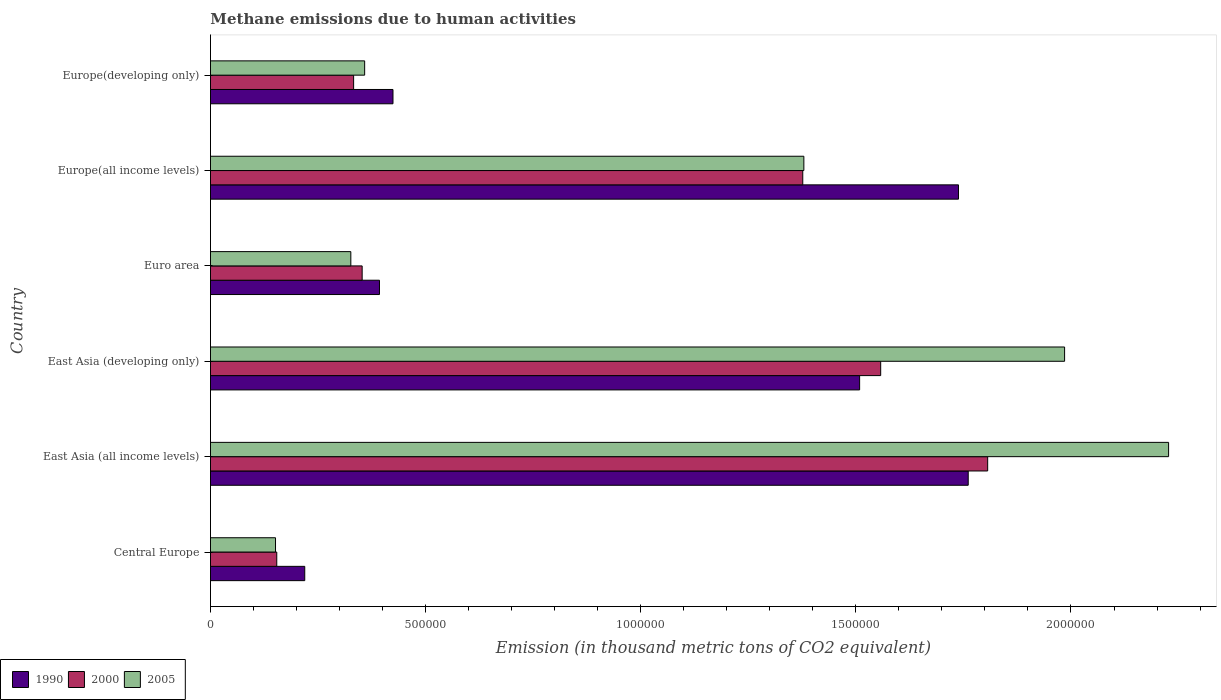How many different coloured bars are there?
Keep it short and to the point. 3. How many groups of bars are there?
Provide a succinct answer. 6. Are the number of bars per tick equal to the number of legend labels?
Your answer should be very brief. Yes. Are the number of bars on each tick of the Y-axis equal?
Offer a terse response. Yes. What is the label of the 1st group of bars from the top?
Keep it short and to the point. Europe(developing only). In how many cases, is the number of bars for a given country not equal to the number of legend labels?
Keep it short and to the point. 0. What is the amount of methane emitted in 1990 in East Asia (developing only)?
Offer a terse response. 1.51e+06. Across all countries, what is the maximum amount of methane emitted in 2005?
Your answer should be very brief. 2.23e+06. Across all countries, what is the minimum amount of methane emitted in 2005?
Provide a succinct answer. 1.51e+05. In which country was the amount of methane emitted in 2000 maximum?
Give a very brief answer. East Asia (all income levels). In which country was the amount of methane emitted in 2005 minimum?
Keep it short and to the point. Central Europe. What is the total amount of methane emitted in 2005 in the graph?
Your answer should be very brief. 6.43e+06. What is the difference between the amount of methane emitted in 2000 in Europe(all income levels) and that in Europe(developing only)?
Your response must be concise. 1.04e+06. What is the difference between the amount of methane emitted in 2000 in Europe(all income levels) and the amount of methane emitted in 2005 in Europe(developing only)?
Your answer should be very brief. 1.02e+06. What is the average amount of methane emitted in 2005 per country?
Ensure brevity in your answer.  1.07e+06. What is the difference between the amount of methane emitted in 1990 and amount of methane emitted in 2005 in Europe(all income levels)?
Keep it short and to the point. 3.59e+05. What is the ratio of the amount of methane emitted in 2000 in East Asia (all income levels) to that in East Asia (developing only)?
Your answer should be compact. 1.16. Is the amount of methane emitted in 1990 in East Asia (all income levels) less than that in Europe(all income levels)?
Your response must be concise. No. What is the difference between the highest and the second highest amount of methane emitted in 1990?
Provide a short and direct response. 2.26e+04. What is the difference between the highest and the lowest amount of methane emitted in 2000?
Keep it short and to the point. 1.65e+06. What does the 1st bar from the top in East Asia (all income levels) represents?
Offer a terse response. 2005. What does the 1st bar from the bottom in Central Europe represents?
Provide a succinct answer. 1990. Are all the bars in the graph horizontal?
Offer a very short reply. Yes. How many countries are there in the graph?
Make the answer very short. 6. Are the values on the major ticks of X-axis written in scientific E-notation?
Give a very brief answer. No. Does the graph contain any zero values?
Keep it short and to the point. No. Does the graph contain grids?
Provide a succinct answer. No. Where does the legend appear in the graph?
Offer a terse response. Bottom left. What is the title of the graph?
Your response must be concise. Methane emissions due to human activities. What is the label or title of the X-axis?
Provide a succinct answer. Emission (in thousand metric tons of CO2 equivalent). What is the Emission (in thousand metric tons of CO2 equivalent) of 1990 in Central Europe?
Keep it short and to the point. 2.19e+05. What is the Emission (in thousand metric tons of CO2 equivalent) of 2000 in Central Europe?
Offer a very short reply. 1.54e+05. What is the Emission (in thousand metric tons of CO2 equivalent) of 2005 in Central Europe?
Provide a short and direct response. 1.51e+05. What is the Emission (in thousand metric tons of CO2 equivalent) in 1990 in East Asia (all income levels)?
Make the answer very short. 1.76e+06. What is the Emission (in thousand metric tons of CO2 equivalent) in 2000 in East Asia (all income levels)?
Provide a succinct answer. 1.81e+06. What is the Emission (in thousand metric tons of CO2 equivalent) in 2005 in East Asia (all income levels)?
Offer a terse response. 2.23e+06. What is the Emission (in thousand metric tons of CO2 equivalent) in 1990 in East Asia (developing only)?
Make the answer very short. 1.51e+06. What is the Emission (in thousand metric tons of CO2 equivalent) in 2000 in East Asia (developing only)?
Offer a very short reply. 1.56e+06. What is the Emission (in thousand metric tons of CO2 equivalent) of 2005 in East Asia (developing only)?
Ensure brevity in your answer.  1.99e+06. What is the Emission (in thousand metric tons of CO2 equivalent) of 1990 in Euro area?
Provide a short and direct response. 3.93e+05. What is the Emission (in thousand metric tons of CO2 equivalent) in 2000 in Euro area?
Provide a succinct answer. 3.53e+05. What is the Emission (in thousand metric tons of CO2 equivalent) of 2005 in Euro area?
Offer a very short reply. 3.26e+05. What is the Emission (in thousand metric tons of CO2 equivalent) in 1990 in Europe(all income levels)?
Provide a short and direct response. 1.74e+06. What is the Emission (in thousand metric tons of CO2 equivalent) in 2000 in Europe(all income levels)?
Give a very brief answer. 1.38e+06. What is the Emission (in thousand metric tons of CO2 equivalent) of 2005 in Europe(all income levels)?
Keep it short and to the point. 1.38e+06. What is the Emission (in thousand metric tons of CO2 equivalent) of 1990 in Europe(developing only)?
Provide a succinct answer. 4.24e+05. What is the Emission (in thousand metric tons of CO2 equivalent) of 2000 in Europe(developing only)?
Provide a short and direct response. 3.33e+05. What is the Emission (in thousand metric tons of CO2 equivalent) in 2005 in Europe(developing only)?
Give a very brief answer. 3.58e+05. Across all countries, what is the maximum Emission (in thousand metric tons of CO2 equivalent) in 1990?
Your response must be concise. 1.76e+06. Across all countries, what is the maximum Emission (in thousand metric tons of CO2 equivalent) in 2000?
Give a very brief answer. 1.81e+06. Across all countries, what is the maximum Emission (in thousand metric tons of CO2 equivalent) of 2005?
Your answer should be very brief. 2.23e+06. Across all countries, what is the minimum Emission (in thousand metric tons of CO2 equivalent) in 1990?
Ensure brevity in your answer.  2.19e+05. Across all countries, what is the minimum Emission (in thousand metric tons of CO2 equivalent) of 2000?
Give a very brief answer. 1.54e+05. Across all countries, what is the minimum Emission (in thousand metric tons of CO2 equivalent) of 2005?
Your answer should be very brief. 1.51e+05. What is the total Emission (in thousand metric tons of CO2 equivalent) in 1990 in the graph?
Make the answer very short. 6.04e+06. What is the total Emission (in thousand metric tons of CO2 equivalent) of 2000 in the graph?
Your response must be concise. 5.58e+06. What is the total Emission (in thousand metric tons of CO2 equivalent) of 2005 in the graph?
Your response must be concise. 6.43e+06. What is the difference between the Emission (in thousand metric tons of CO2 equivalent) in 1990 in Central Europe and that in East Asia (all income levels)?
Offer a very short reply. -1.54e+06. What is the difference between the Emission (in thousand metric tons of CO2 equivalent) of 2000 in Central Europe and that in East Asia (all income levels)?
Your answer should be compact. -1.65e+06. What is the difference between the Emission (in thousand metric tons of CO2 equivalent) in 2005 in Central Europe and that in East Asia (all income levels)?
Ensure brevity in your answer.  -2.08e+06. What is the difference between the Emission (in thousand metric tons of CO2 equivalent) in 1990 in Central Europe and that in East Asia (developing only)?
Provide a short and direct response. -1.29e+06. What is the difference between the Emission (in thousand metric tons of CO2 equivalent) of 2000 in Central Europe and that in East Asia (developing only)?
Give a very brief answer. -1.40e+06. What is the difference between the Emission (in thousand metric tons of CO2 equivalent) in 2005 in Central Europe and that in East Asia (developing only)?
Offer a terse response. -1.83e+06. What is the difference between the Emission (in thousand metric tons of CO2 equivalent) of 1990 in Central Europe and that in Euro area?
Ensure brevity in your answer.  -1.74e+05. What is the difference between the Emission (in thousand metric tons of CO2 equivalent) of 2000 in Central Europe and that in Euro area?
Provide a short and direct response. -1.98e+05. What is the difference between the Emission (in thousand metric tons of CO2 equivalent) of 2005 in Central Europe and that in Euro area?
Provide a succinct answer. -1.75e+05. What is the difference between the Emission (in thousand metric tons of CO2 equivalent) in 1990 in Central Europe and that in Europe(all income levels)?
Keep it short and to the point. -1.52e+06. What is the difference between the Emission (in thousand metric tons of CO2 equivalent) of 2000 in Central Europe and that in Europe(all income levels)?
Make the answer very short. -1.22e+06. What is the difference between the Emission (in thousand metric tons of CO2 equivalent) of 2005 in Central Europe and that in Europe(all income levels)?
Make the answer very short. -1.23e+06. What is the difference between the Emission (in thousand metric tons of CO2 equivalent) of 1990 in Central Europe and that in Europe(developing only)?
Ensure brevity in your answer.  -2.05e+05. What is the difference between the Emission (in thousand metric tons of CO2 equivalent) in 2000 in Central Europe and that in Europe(developing only)?
Provide a succinct answer. -1.79e+05. What is the difference between the Emission (in thousand metric tons of CO2 equivalent) in 2005 in Central Europe and that in Europe(developing only)?
Provide a short and direct response. -2.07e+05. What is the difference between the Emission (in thousand metric tons of CO2 equivalent) in 1990 in East Asia (all income levels) and that in East Asia (developing only)?
Keep it short and to the point. 2.52e+05. What is the difference between the Emission (in thousand metric tons of CO2 equivalent) of 2000 in East Asia (all income levels) and that in East Asia (developing only)?
Provide a short and direct response. 2.49e+05. What is the difference between the Emission (in thousand metric tons of CO2 equivalent) in 2005 in East Asia (all income levels) and that in East Asia (developing only)?
Your answer should be compact. 2.42e+05. What is the difference between the Emission (in thousand metric tons of CO2 equivalent) of 1990 in East Asia (all income levels) and that in Euro area?
Offer a terse response. 1.37e+06. What is the difference between the Emission (in thousand metric tons of CO2 equivalent) in 2000 in East Asia (all income levels) and that in Euro area?
Provide a short and direct response. 1.45e+06. What is the difference between the Emission (in thousand metric tons of CO2 equivalent) in 2005 in East Asia (all income levels) and that in Euro area?
Offer a terse response. 1.90e+06. What is the difference between the Emission (in thousand metric tons of CO2 equivalent) in 1990 in East Asia (all income levels) and that in Europe(all income levels)?
Make the answer very short. 2.26e+04. What is the difference between the Emission (in thousand metric tons of CO2 equivalent) in 2000 in East Asia (all income levels) and that in Europe(all income levels)?
Your response must be concise. 4.30e+05. What is the difference between the Emission (in thousand metric tons of CO2 equivalent) of 2005 in East Asia (all income levels) and that in Europe(all income levels)?
Offer a terse response. 8.48e+05. What is the difference between the Emission (in thousand metric tons of CO2 equivalent) in 1990 in East Asia (all income levels) and that in Europe(developing only)?
Your response must be concise. 1.34e+06. What is the difference between the Emission (in thousand metric tons of CO2 equivalent) in 2000 in East Asia (all income levels) and that in Europe(developing only)?
Your answer should be very brief. 1.47e+06. What is the difference between the Emission (in thousand metric tons of CO2 equivalent) of 2005 in East Asia (all income levels) and that in Europe(developing only)?
Your answer should be compact. 1.87e+06. What is the difference between the Emission (in thousand metric tons of CO2 equivalent) in 1990 in East Asia (developing only) and that in Euro area?
Keep it short and to the point. 1.12e+06. What is the difference between the Emission (in thousand metric tons of CO2 equivalent) in 2000 in East Asia (developing only) and that in Euro area?
Keep it short and to the point. 1.21e+06. What is the difference between the Emission (in thousand metric tons of CO2 equivalent) of 2005 in East Asia (developing only) and that in Euro area?
Your answer should be very brief. 1.66e+06. What is the difference between the Emission (in thousand metric tons of CO2 equivalent) of 1990 in East Asia (developing only) and that in Europe(all income levels)?
Make the answer very short. -2.30e+05. What is the difference between the Emission (in thousand metric tons of CO2 equivalent) in 2000 in East Asia (developing only) and that in Europe(all income levels)?
Keep it short and to the point. 1.81e+05. What is the difference between the Emission (in thousand metric tons of CO2 equivalent) in 2005 in East Asia (developing only) and that in Europe(all income levels)?
Provide a succinct answer. 6.06e+05. What is the difference between the Emission (in thousand metric tons of CO2 equivalent) in 1990 in East Asia (developing only) and that in Europe(developing only)?
Make the answer very short. 1.08e+06. What is the difference between the Emission (in thousand metric tons of CO2 equivalent) in 2000 in East Asia (developing only) and that in Europe(developing only)?
Give a very brief answer. 1.23e+06. What is the difference between the Emission (in thousand metric tons of CO2 equivalent) in 2005 in East Asia (developing only) and that in Europe(developing only)?
Keep it short and to the point. 1.63e+06. What is the difference between the Emission (in thousand metric tons of CO2 equivalent) of 1990 in Euro area and that in Europe(all income levels)?
Offer a terse response. -1.35e+06. What is the difference between the Emission (in thousand metric tons of CO2 equivalent) in 2000 in Euro area and that in Europe(all income levels)?
Provide a short and direct response. -1.02e+06. What is the difference between the Emission (in thousand metric tons of CO2 equivalent) in 2005 in Euro area and that in Europe(all income levels)?
Offer a very short reply. -1.05e+06. What is the difference between the Emission (in thousand metric tons of CO2 equivalent) of 1990 in Euro area and that in Europe(developing only)?
Give a very brief answer. -3.14e+04. What is the difference between the Emission (in thousand metric tons of CO2 equivalent) in 2000 in Euro area and that in Europe(developing only)?
Give a very brief answer. 1.98e+04. What is the difference between the Emission (in thousand metric tons of CO2 equivalent) in 2005 in Euro area and that in Europe(developing only)?
Offer a very short reply. -3.22e+04. What is the difference between the Emission (in thousand metric tons of CO2 equivalent) in 1990 in Europe(all income levels) and that in Europe(developing only)?
Offer a terse response. 1.31e+06. What is the difference between the Emission (in thousand metric tons of CO2 equivalent) of 2000 in Europe(all income levels) and that in Europe(developing only)?
Ensure brevity in your answer.  1.04e+06. What is the difference between the Emission (in thousand metric tons of CO2 equivalent) in 2005 in Europe(all income levels) and that in Europe(developing only)?
Offer a terse response. 1.02e+06. What is the difference between the Emission (in thousand metric tons of CO2 equivalent) in 1990 in Central Europe and the Emission (in thousand metric tons of CO2 equivalent) in 2000 in East Asia (all income levels)?
Offer a very short reply. -1.59e+06. What is the difference between the Emission (in thousand metric tons of CO2 equivalent) of 1990 in Central Europe and the Emission (in thousand metric tons of CO2 equivalent) of 2005 in East Asia (all income levels)?
Offer a terse response. -2.01e+06. What is the difference between the Emission (in thousand metric tons of CO2 equivalent) in 2000 in Central Europe and the Emission (in thousand metric tons of CO2 equivalent) in 2005 in East Asia (all income levels)?
Your answer should be compact. -2.07e+06. What is the difference between the Emission (in thousand metric tons of CO2 equivalent) in 1990 in Central Europe and the Emission (in thousand metric tons of CO2 equivalent) in 2000 in East Asia (developing only)?
Provide a short and direct response. -1.34e+06. What is the difference between the Emission (in thousand metric tons of CO2 equivalent) of 1990 in Central Europe and the Emission (in thousand metric tons of CO2 equivalent) of 2005 in East Asia (developing only)?
Your response must be concise. -1.77e+06. What is the difference between the Emission (in thousand metric tons of CO2 equivalent) of 2000 in Central Europe and the Emission (in thousand metric tons of CO2 equivalent) of 2005 in East Asia (developing only)?
Give a very brief answer. -1.83e+06. What is the difference between the Emission (in thousand metric tons of CO2 equivalent) in 1990 in Central Europe and the Emission (in thousand metric tons of CO2 equivalent) in 2000 in Euro area?
Offer a very short reply. -1.33e+05. What is the difference between the Emission (in thousand metric tons of CO2 equivalent) of 1990 in Central Europe and the Emission (in thousand metric tons of CO2 equivalent) of 2005 in Euro area?
Your answer should be compact. -1.07e+05. What is the difference between the Emission (in thousand metric tons of CO2 equivalent) in 2000 in Central Europe and the Emission (in thousand metric tons of CO2 equivalent) in 2005 in Euro area?
Your response must be concise. -1.72e+05. What is the difference between the Emission (in thousand metric tons of CO2 equivalent) of 1990 in Central Europe and the Emission (in thousand metric tons of CO2 equivalent) of 2000 in Europe(all income levels)?
Provide a succinct answer. -1.16e+06. What is the difference between the Emission (in thousand metric tons of CO2 equivalent) of 1990 in Central Europe and the Emission (in thousand metric tons of CO2 equivalent) of 2005 in Europe(all income levels)?
Your answer should be compact. -1.16e+06. What is the difference between the Emission (in thousand metric tons of CO2 equivalent) in 2000 in Central Europe and the Emission (in thousand metric tons of CO2 equivalent) in 2005 in Europe(all income levels)?
Provide a succinct answer. -1.23e+06. What is the difference between the Emission (in thousand metric tons of CO2 equivalent) of 1990 in Central Europe and the Emission (in thousand metric tons of CO2 equivalent) of 2000 in Europe(developing only)?
Your response must be concise. -1.14e+05. What is the difference between the Emission (in thousand metric tons of CO2 equivalent) of 1990 in Central Europe and the Emission (in thousand metric tons of CO2 equivalent) of 2005 in Europe(developing only)?
Provide a short and direct response. -1.39e+05. What is the difference between the Emission (in thousand metric tons of CO2 equivalent) of 2000 in Central Europe and the Emission (in thousand metric tons of CO2 equivalent) of 2005 in Europe(developing only)?
Your answer should be very brief. -2.04e+05. What is the difference between the Emission (in thousand metric tons of CO2 equivalent) of 1990 in East Asia (all income levels) and the Emission (in thousand metric tons of CO2 equivalent) of 2000 in East Asia (developing only)?
Offer a very short reply. 2.03e+05. What is the difference between the Emission (in thousand metric tons of CO2 equivalent) in 1990 in East Asia (all income levels) and the Emission (in thousand metric tons of CO2 equivalent) in 2005 in East Asia (developing only)?
Provide a short and direct response. -2.24e+05. What is the difference between the Emission (in thousand metric tons of CO2 equivalent) of 2000 in East Asia (all income levels) and the Emission (in thousand metric tons of CO2 equivalent) of 2005 in East Asia (developing only)?
Keep it short and to the point. -1.79e+05. What is the difference between the Emission (in thousand metric tons of CO2 equivalent) in 1990 in East Asia (all income levels) and the Emission (in thousand metric tons of CO2 equivalent) in 2000 in Euro area?
Your response must be concise. 1.41e+06. What is the difference between the Emission (in thousand metric tons of CO2 equivalent) in 1990 in East Asia (all income levels) and the Emission (in thousand metric tons of CO2 equivalent) in 2005 in Euro area?
Make the answer very short. 1.43e+06. What is the difference between the Emission (in thousand metric tons of CO2 equivalent) of 2000 in East Asia (all income levels) and the Emission (in thousand metric tons of CO2 equivalent) of 2005 in Euro area?
Ensure brevity in your answer.  1.48e+06. What is the difference between the Emission (in thousand metric tons of CO2 equivalent) of 1990 in East Asia (all income levels) and the Emission (in thousand metric tons of CO2 equivalent) of 2000 in Europe(all income levels)?
Provide a short and direct response. 3.85e+05. What is the difference between the Emission (in thousand metric tons of CO2 equivalent) in 1990 in East Asia (all income levels) and the Emission (in thousand metric tons of CO2 equivalent) in 2005 in Europe(all income levels)?
Offer a terse response. 3.82e+05. What is the difference between the Emission (in thousand metric tons of CO2 equivalent) in 2000 in East Asia (all income levels) and the Emission (in thousand metric tons of CO2 equivalent) in 2005 in Europe(all income levels)?
Your answer should be compact. 4.27e+05. What is the difference between the Emission (in thousand metric tons of CO2 equivalent) of 1990 in East Asia (all income levels) and the Emission (in thousand metric tons of CO2 equivalent) of 2000 in Europe(developing only)?
Keep it short and to the point. 1.43e+06. What is the difference between the Emission (in thousand metric tons of CO2 equivalent) of 1990 in East Asia (all income levels) and the Emission (in thousand metric tons of CO2 equivalent) of 2005 in Europe(developing only)?
Keep it short and to the point. 1.40e+06. What is the difference between the Emission (in thousand metric tons of CO2 equivalent) in 2000 in East Asia (all income levels) and the Emission (in thousand metric tons of CO2 equivalent) in 2005 in Europe(developing only)?
Your answer should be very brief. 1.45e+06. What is the difference between the Emission (in thousand metric tons of CO2 equivalent) in 1990 in East Asia (developing only) and the Emission (in thousand metric tons of CO2 equivalent) in 2000 in Euro area?
Give a very brief answer. 1.16e+06. What is the difference between the Emission (in thousand metric tons of CO2 equivalent) of 1990 in East Asia (developing only) and the Emission (in thousand metric tons of CO2 equivalent) of 2005 in Euro area?
Make the answer very short. 1.18e+06. What is the difference between the Emission (in thousand metric tons of CO2 equivalent) in 2000 in East Asia (developing only) and the Emission (in thousand metric tons of CO2 equivalent) in 2005 in Euro area?
Make the answer very short. 1.23e+06. What is the difference between the Emission (in thousand metric tons of CO2 equivalent) in 1990 in East Asia (developing only) and the Emission (in thousand metric tons of CO2 equivalent) in 2000 in Europe(all income levels)?
Keep it short and to the point. 1.32e+05. What is the difference between the Emission (in thousand metric tons of CO2 equivalent) of 1990 in East Asia (developing only) and the Emission (in thousand metric tons of CO2 equivalent) of 2005 in Europe(all income levels)?
Keep it short and to the point. 1.30e+05. What is the difference between the Emission (in thousand metric tons of CO2 equivalent) in 2000 in East Asia (developing only) and the Emission (in thousand metric tons of CO2 equivalent) in 2005 in Europe(all income levels)?
Give a very brief answer. 1.79e+05. What is the difference between the Emission (in thousand metric tons of CO2 equivalent) in 1990 in East Asia (developing only) and the Emission (in thousand metric tons of CO2 equivalent) in 2000 in Europe(developing only)?
Your response must be concise. 1.18e+06. What is the difference between the Emission (in thousand metric tons of CO2 equivalent) of 1990 in East Asia (developing only) and the Emission (in thousand metric tons of CO2 equivalent) of 2005 in Europe(developing only)?
Keep it short and to the point. 1.15e+06. What is the difference between the Emission (in thousand metric tons of CO2 equivalent) of 2000 in East Asia (developing only) and the Emission (in thousand metric tons of CO2 equivalent) of 2005 in Europe(developing only)?
Your answer should be compact. 1.20e+06. What is the difference between the Emission (in thousand metric tons of CO2 equivalent) of 1990 in Euro area and the Emission (in thousand metric tons of CO2 equivalent) of 2000 in Europe(all income levels)?
Provide a succinct answer. -9.84e+05. What is the difference between the Emission (in thousand metric tons of CO2 equivalent) in 1990 in Euro area and the Emission (in thousand metric tons of CO2 equivalent) in 2005 in Europe(all income levels)?
Your answer should be compact. -9.86e+05. What is the difference between the Emission (in thousand metric tons of CO2 equivalent) of 2000 in Euro area and the Emission (in thousand metric tons of CO2 equivalent) of 2005 in Europe(all income levels)?
Your answer should be very brief. -1.03e+06. What is the difference between the Emission (in thousand metric tons of CO2 equivalent) in 1990 in Euro area and the Emission (in thousand metric tons of CO2 equivalent) in 2000 in Europe(developing only)?
Give a very brief answer. 6.01e+04. What is the difference between the Emission (in thousand metric tons of CO2 equivalent) of 1990 in Euro area and the Emission (in thousand metric tons of CO2 equivalent) of 2005 in Europe(developing only)?
Your answer should be compact. 3.44e+04. What is the difference between the Emission (in thousand metric tons of CO2 equivalent) in 2000 in Euro area and the Emission (in thousand metric tons of CO2 equivalent) in 2005 in Europe(developing only)?
Your answer should be compact. -5815.2. What is the difference between the Emission (in thousand metric tons of CO2 equivalent) in 1990 in Europe(all income levels) and the Emission (in thousand metric tons of CO2 equivalent) in 2000 in Europe(developing only)?
Ensure brevity in your answer.  1.41e+06. What is the difference between the Emission (in thousand metric tons of CO2 equivalent) of 1990 in Europe(all income levels) and the Emission (in thousand metric tons of CO2 equivalent) of 2005 in Europe(developing only)?
Your answer should be very brief. 1.38e+06. What is the difference between the Emission (in thousand metric tons of CO2 equivalent) of 2000 in Europe(all income levels) and the Emission (in thousand metric tons of CO2 equivalent) of 2005 in Europe(developing only)?
Provide a succinct answer. 1.02e+06. What is the average Emission (in thousand metric tons of CO2 equivalent) of 1990 per country?
Your response must be concise. 1.01e+06. What is the average Emission (in thousand metric tons of CO2 equivalent) in 2000 per country?
Keep it short and to the point. 9.30e+05. What is the average Emission (in thousand metric tons of CO2 equivalent) in 2005 per country?
Offer a very short reply. 1.07e+06. What is the difference between the Emission (in thousand metric tons of CO2 equivalent) of 1990 and Emission (in thousand metric tons of CO2 equivalent) of 2000 in Central Europe?
Provide a short and direct response. 6.50e+04. What is the difference between the Emission (in thousand metric tons of CO2 equivalent) of 1990 and Emission (in thousand metric tons of CO2 equivalent) of 2005 in Central Europe?
Your response must be concise. 6.80e+04. What is the difference between the Emission (in thousand metric tons of CO2 equivalent) in 2000 and Emission (in thousand metric tons of CO2 equivalent) in 2005 in Central Europe?
Provide a succinct answer. 2935.3. What is the difference between the Emission (in thousand metric tons of CO2 equivalent) of 1990 and Emission (in thousand metric tons of CO2 equivalent) of 2000 in East Asia (all income levels)?
Ensure brevity in your answer.  -4.52e+04. What is the difference between the Emission (in thousand metric tons of CO2 equivalent) of 1990 and Emission (in thousand metric tons of CO2 equivalent) of 2005 in East Asia (all income levels)?
Provide a succinct answer. -4.66e+05. What is the difference between the Emission (in thousand metric tons of CO2 equivalent) of 2000 and Emission (in thousand metric tons of CO2 equivalent) of 2005 in East Asia (all income levels)?
Give a very brief answer. -4.20e+05. What is the difference between the Emission (in thousand metric tons of CO2 equivalent) in 1990 and Emission (in thousand metric tons of CO2 equivalent) in 2000 in East Asia (developing only)?
Make the answer very short. -4.90e+04. What is the difference between the Emission (in thousand metric tons of CO2 equivalent) of 1990 and Emission (in thousand metric tons of CO2 equivalent) of 2005 in East Asia (developing only)?
Keep it short and to the point. -4.76e+05. What is the difference between the Emission (in thousand metric tons of CO2 equivalent) of 2000 and Emission (in thousand metric tons of CO2 equivalent) of 2005 in East Asia (developing only)?
Ensure brevity in your answer.  -4.27e+05. What is the difference between the Emission (in thousand metric tons of CO2 equivalent) in 1990 and Emission (in thousand metric tons of CO2 equivalent) in 2000 in Euro area?
Provide a short and direct response. 4.02e+04. What is the difference between the Emission (in thousand metric tons of CO2 equivalent) of 1990 and Emission (in thousand metric tons of CO2 equivalent) of 2005 in Euro area?
Your answer should be very brief. 6.66e+04. What is the difference between the Emission (in thousand metric tons of CO2 equivalent) of 2000 and Emission (in thousand metric tons of CO2 equivalent) of 2005 in Euro area?
Give a very brief answer. 2.63e+04. What is the difference between the Emission (in thousand metric tons of CO2 equivalent) in 1990 and Emission (in thousand metric tons of CO2 equivalent) in 2000 in Europe(all income levels)?
Your response must be concise. 3.62e+05. What is the difference between the Emission (in thousand metric tons of CO2 equivalent) of 1990 and Emission (in thousand metric tons of CO2 equivalent) of 2005 in Europe(all income levels)?
Offer a very short reply. 3.59e+05. What is the difference between the Emission (in thousand metric tons of CO2 equivalent) of 2000 and Emission (in thousand metric tons of CO2 equivalent) of 2005 in Europe(all income levels)?
Your response must be concise. -2537.9. What is the difference between the Emission (in thousand metric tons of CO2 equivalent) of 1990 and Emission (in thousand metric tons of CO2 equivalent) of 2000 in Europe(developing only)?
Your response must be concise. 9.15e+04. What is the difference between the Emission (in thousand metric tons of CO2 equivalent) of 1990 and Emission (in thousand metric tons of CO2 equivalent) of 2005 in Europe(developing only)?
Your answer should be compact. 6.58e+04. What is the difference between the Emission (in thousand metric tons of CO2 equivalent) of 2000 and Emission (in thousand metric tons of CO2 equivalent) of 2005 in Europe(developing only)?
Your answer should be very brief. -2.56e+04. What is the ratio of the Emission (in thousand metric tons of CO2 equivalent) of 1990 in Central Europe to that in East Asia (all income levels)?
Offer a very short reply. 0.12. What is the ratio of the Emission (in thousand metric tons of CO2 equivalent) of 2000 in Central Europe to that in East Asia (all income levels)?
Give a very brief answer. 0.09. What is the ratio of the Emission (in thousand metric tons of CO2 equivalent) of 2005 in Central Europe to that in East Asia (all income levels)?
Give a very brief answer. 0.07. What is the ratio of the Emission (in thousand metric tons of CO2 equivalent) in 1990 in Central Europe to that in East Asia (developing only)?
Offer a very short reply. 0.15. What is the ratio of the Emission (in thousand metric tons of CO2 equivalent) of 2000 in Central Europe to that in East Asia (developing only)?
Ensure brevity in your answer.  0.1. What is the ratio of the Emission (in thousand metric tons of CO2 equivalent) of 2005 in Central Europe to that in East Asia (developing only)?
Your answer should be compact. 0.08. What is the ratio of the Emission (in thousand metric tons of CO2 equivalent) in 1990 in Central Europe to that in Euro area?
Make the answer very short. 0.56. What is the ratio of the Emission (in thousand metric tons of CO2 equivalent) in 2000 in Central Europe to that in Euro area?
Your answer should be very brief. 0.44. What is the ratio of the Emission (in thousand metric tons of CO2 equivalent) in 2005 in Central Europe to that in Euro area?
Give a very brief answer. 0.46. What is the ratio of the Emission (in thousand metric tons of CO2 equivalent) of 1990 in Central Europe to that in Europe(all income levels)?
Make the answer very short. 0.13. What is the ratio of the Emission (in thousand metric tons of CO2 equivalent) of 2000 in Central Europe to that in Europe(all income levels)?
Make the answer very short. 0.11. What is the ratio of the Emission (in thousand metric tons of CO2 equivalent) of 2005 in Central Europe to that in Europe(all income levels)?
Provide a short and direct response. 0.11. What is the ratio of the Emission (in thousand metric tons of CO2 equivalent) of 1990 in Central Europe to that in Europe(developing only)?
Your response must be concise. 0.52. What is the ratio of the Emission (in thousand metric tons of CO2 equivalent) in 2000 in Central Europe to that in Europe(developing only)?
Keep it short and to the point. 0.46. What is the ratio of the Emission (in thousand metric tons of CO2 equivalent) in 2005 in Central Europe to that in Europe(developing only)?
Give a very brief answer. 0.42. What is the ratio of the Emission (in thousand metric tons of CO2 equivalent) in 1990 in East Asia (all income levels) to that in East Asia (developing only)?
Your response must be concise. 1.17. What is the ratio of the Emission (in thousand metric tons of CO2 equivalent) of 2000 in East Asia (all income levels) to that in East Asia (developing only)?
Your answer should be very brief. 1.16. What is the ratio of the Emission (in thousand metric tons of CO2 equivalent) in 2005 in East Asia (all income levels) to that in East Asia (developing only)?
Provide a succinct answer. 1.12. What is the ratio of the Emission (in thousand metric tons of CO2 equivalent) in 1990 in East Asia (all income levels) to that in Euro area?
Your answer should be compact. 4.48. What is the ratio of the Emission (in thousand metric tons of CO2 equivalent) of 2000 in East Asia (all income levels) to that in Euro area?
Your response must be concise. 5.12. What is the ratio of the Emission (in thousand metric tons of CO2 equivalent) of 2005 in East Asia (all income levels) to that in Euro area?
Provide a short and direct response. 6.83. What is the ratio of the Emission (in thousand metric tons of CO2 equivalent) of 1990 in East Asia (all income levels) to that in Europe(all income levels)?
Offer a terse response. 1.01. What is the ratio of the Emission (in thousand metric tons of CO2 equivalent) in 2000 in East Asia (all income levels) to that in Europe(all income levels)?
Your answer should be very brief. 1.31. What is the ratio of the Emission (in thousand metric tons of CO2 equivalent) in 2005 in East Asia (all income levels) to that in Europe(all income levels)?
Offer a very short reply. 1.61. What is the ratio of the Emission (in thousand metric tons of CO2 equivalent) in 1990 in East Asia (all income levels) to that in Europe(developing only)?
Provide a short and direct response. 4.15. What is the ratio of the Emission (in thousand metric tons of CO2 equivalent) of 2000 in East Asia (all income levels) to that in Europe(developing only)?
Ensure brevity in your answer.  5.43. What is the ratio of the Emission (in thousand metric tons of CO2 equivalent) in 2005 in East Asia (all income levels) to that in Europe(developing only)?
Make the answer very short. 6.21. What is the ratio of the Emission (in thousand metric tons of CO2 equivalent) of 1990 in East Asia (developing only) to that in Euro area?
Provide a short and direct response. 3.84. What is the ratio of the Emission (in thousand metric tons of CO2 equivalent) in 2000 in East Asia (developing only) to that in Euro area?
Offer a very short reply. 4.42. What is the ratio of the Emission (in thousand metric tons of CO2 equivalent) in 2005 in East Asia (developing only) to that in Euro area?
Your answer should be compact. 6.09. What is the ratio of the Emission (in thousand metric tons of CO2 equivalent) of 1990 in East Asia (developing only) to that in Europe(all income levels)?
Your answer should be compact. 0.87. What is the ratio of the Emission (in thousand metric tons of CO2 equivalent) in 2000 in East Asia (developing only) to that in Europe(all income levels)?
Your answer should be very brief. 1.13. What is the ratio of the Emission (in thousand metric tons of CO2 equivalent) of 2005 in East Asia (developing only) to that in Europe(all income levels)?
Offer a very short reply. 1.44. What is the ratio of the Emission (in thousand metric tons of CO2 equivalent) of 1990 in East Asia (developing only) to that in Europe(developing only)?
Your answer should be very brief. 3.56. What is the ratio of the Emission (in thousand metric tons of CO2 equivalent) of 2000 in East Asia (developing only) to that in Europe(developing only)?
Make the answer very short. 4.68. What is the ratio of the Emission (in thousand metric tons of CO2 equivalent) of 2005 in East Asia (developing only) to that in Europe(developing only)?
Your answer should be compact. 5.54. What is the ratio of the Emission (in thousand metric tons of CO2 equivalent) in 1990 in Euro area to that in Europe(all income levels)?
Ensure brevity in your answer.  0.23. What is the ratio of the Emission (in thousand metric tons of CO2 equivalent) of 2000 in Euro area to that in Europe(all income levels)?
Your response must be concise. 0.26. What is the ratio of the Emission (in thousand metric tons of CO2 equivalent) in 2005 in Euro area to that in Europe(all income levels)?
Provide a short and direct response. 0.24. What is the ratio of the Emission (in thousand metric tons of CO2 equivalent) in 1990 in Euro area to that in Europe(developing only)?
Your answer should be compact. 0.93. What is the ratio of the Emission (in thousand metric tons of CO2 equivalent) in 2000 in Euro area to that in Europe(developing only)?
Your response must be concise. 1.06. What is the ratio of the Emission (in thousand metric tons of CO2 equivalent) of 2005 in Euro area to that in Europe(developing only)?
Provide a short and direct response. 0.91. What is the ratio of the Emission (in thousand metric tons of CO2 equivalent) of 1990 in Europe(all income levels) to that in Europe(developing only)?
Make the answer very short. 4.1. What is the ratio of the Emission (in thousand metric tons of CO2 equivalent) in 2000 in Europe(all income levels) to that in Europe(developing only)?
Offer a terse response. 4.14. What is the ratio of the Emission (in thousand metric tons of CO2 equivalent) in 2005 in Europe(all income levels) to that in Europe(developing only)?
Give a very brief answer. 3.85. What is the difference between the highest and the second highest Emission (in thousand metric tons of CO2 equivalent) in 1990?
Offer a terse response. 2.26e+04. What is the difference between the highest and the second highest Emission (in thousand metric tons of CO2 equivalent) of 2000?
Give a very brief answer. 2.49e+05. What is the difference between the highest and the second highest Emission (in thousand metric tons of CO2 equivalent) in 2005?
Provide a short and direct response. 2.42e+05. What is the difference between the highest and the lowest Emission (in thousand metric tons of CO2 equivalent) of 1990?
Provide a succinct answer. 1.54e+06. What is the difference between the highest and the lowest Emission (in thousand metric tons of CO2 equivalent) in 2000?
Your answer should be compact. 1.65e+06. What is the difference between the highest and the lowest Emission (in thousand metric tons of CO2 equivalent) in 2005?
Make the answer very short. 2.08e+06. 